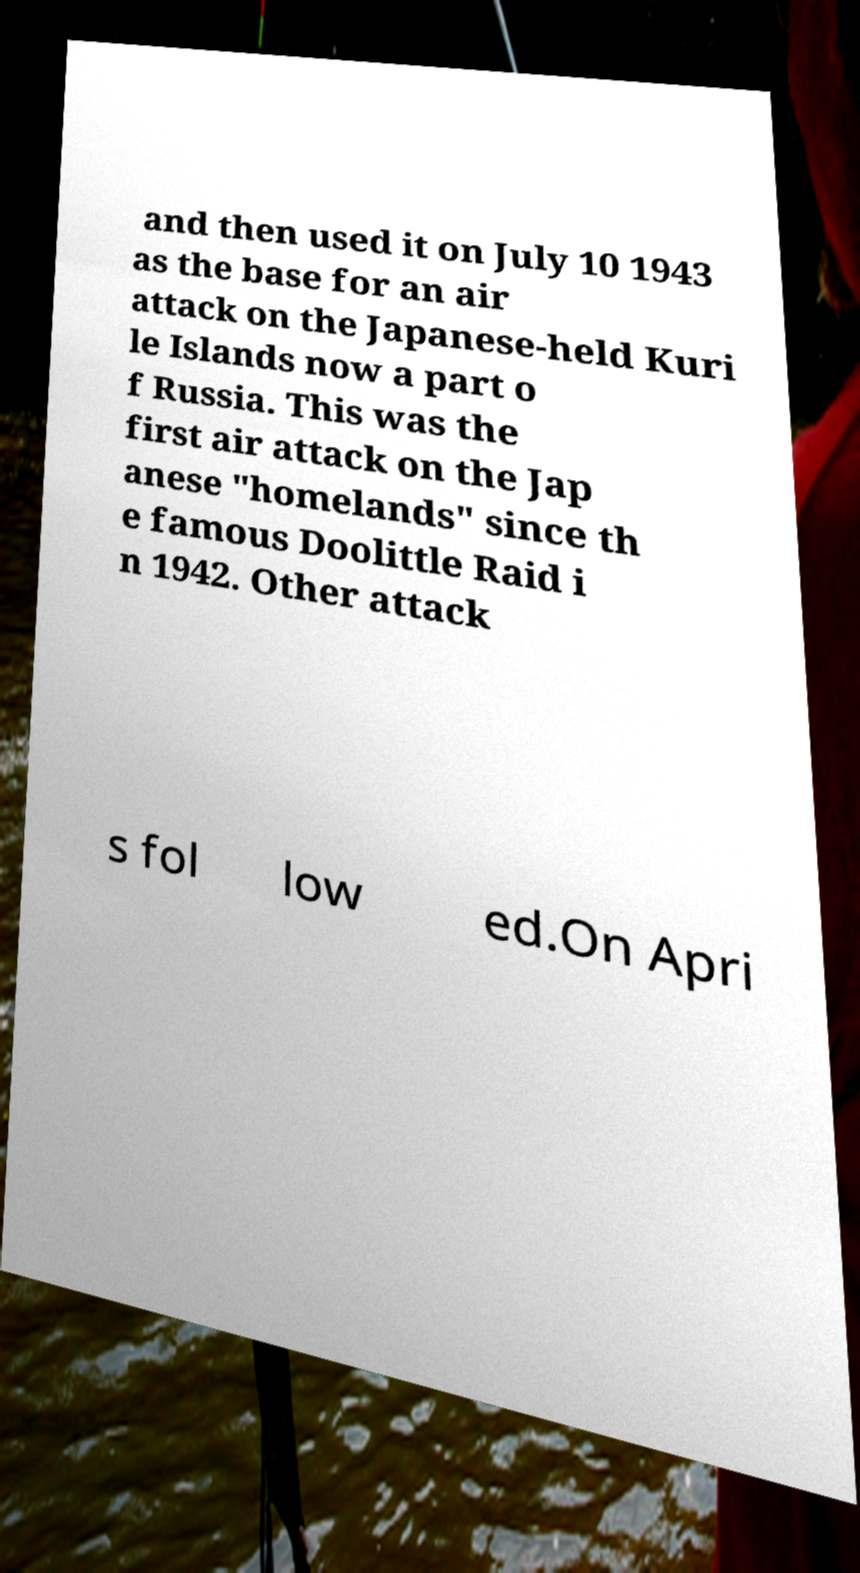Could you assist in decoding the text presented in this image and type it out clearly? and then used it on July 10 1943 as the base for an air attack on the Japanese-held Kuri le Islands now a part o f Russia. This was the first air attack on the Jap anese "homelands" since th e famous Doolittle Raid i n 1942. Other attack s fol low ed.On Apri 